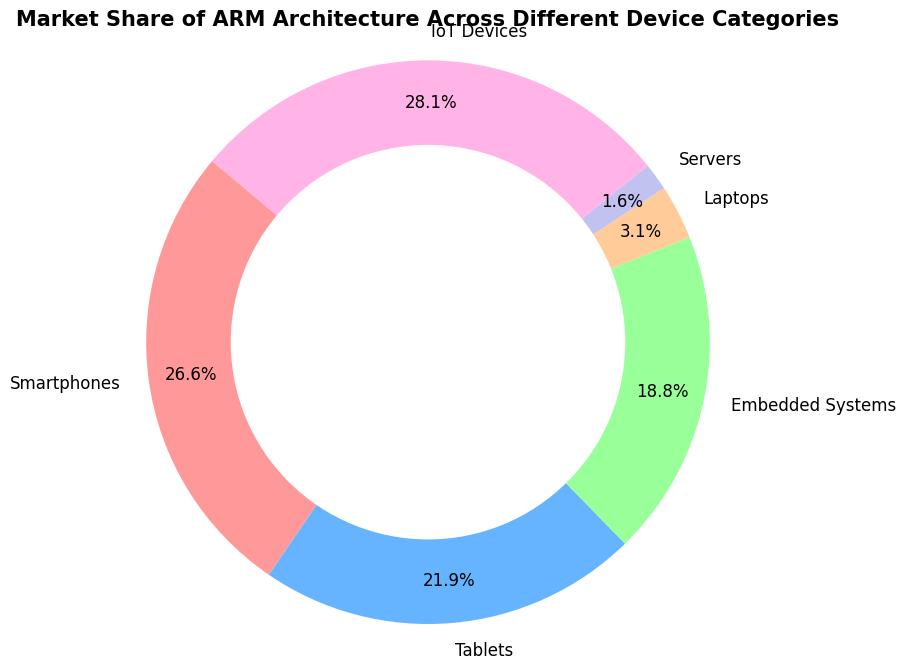What category has the largest market share? By looking at the ring chart, the segment with the largest area represents IoT Devices, which covers 90% of the market.
Answer: IoT Devices What category has the smallest market share? The segment representing Servers has the smallest area in the ring chart, indicating it has only 5% of the market.
Answer: Servers What is the market share difference between Smartphones and Tablets? The market share of Smartphones is 85%, and the market share of Tablets is 70%. The difference is 85% - 70% = 15%.
Answer: 15% Which category has a higher market share: Laptops or Embedded Systems? By comparing the segments in the ring chart, Embedded Systems has a larger area (60%) compared to Laptops (10%).
Answer: Embedded Systems What is the combined market share of Laptops and Servers? The market share of Laptops is 10% and that of Servers is 5%. Adding them together: 10% + 5% = 15%.
Answer: 15% How does the market share of Tablets compare to that of IoT Devices? Tablets have a market share of 70%, while IoT Devices have a market share of 90%. IoT Devices have a higher market share than Tablets.
Answer: IoT Devices What is the average market share of all device categories? The market shares are {85, 70, 60, 10, 5, 90}. Summing them up: 85 + 70 + 60 + 10 + 5 + 90 = 320. There are 6 categories, so the average is 320 / 6 ≈ 53.33%.
Answer: 53.33% What is the ratio of the market share of Smartphones to Servers? The market share of Smartphones is 85%, and that of Servers is 5%. The ratio is 85 / 5 = 17.
Answer: 17 What is the percentage difference between the market share of Tablets and Embedded Systems? The market share of Tablets is 70% and that of Embedded Systems is 60%. The percentage difference is ((70 - 60) / 70) * 100% = 14.29%.
Answer: 14.29% 